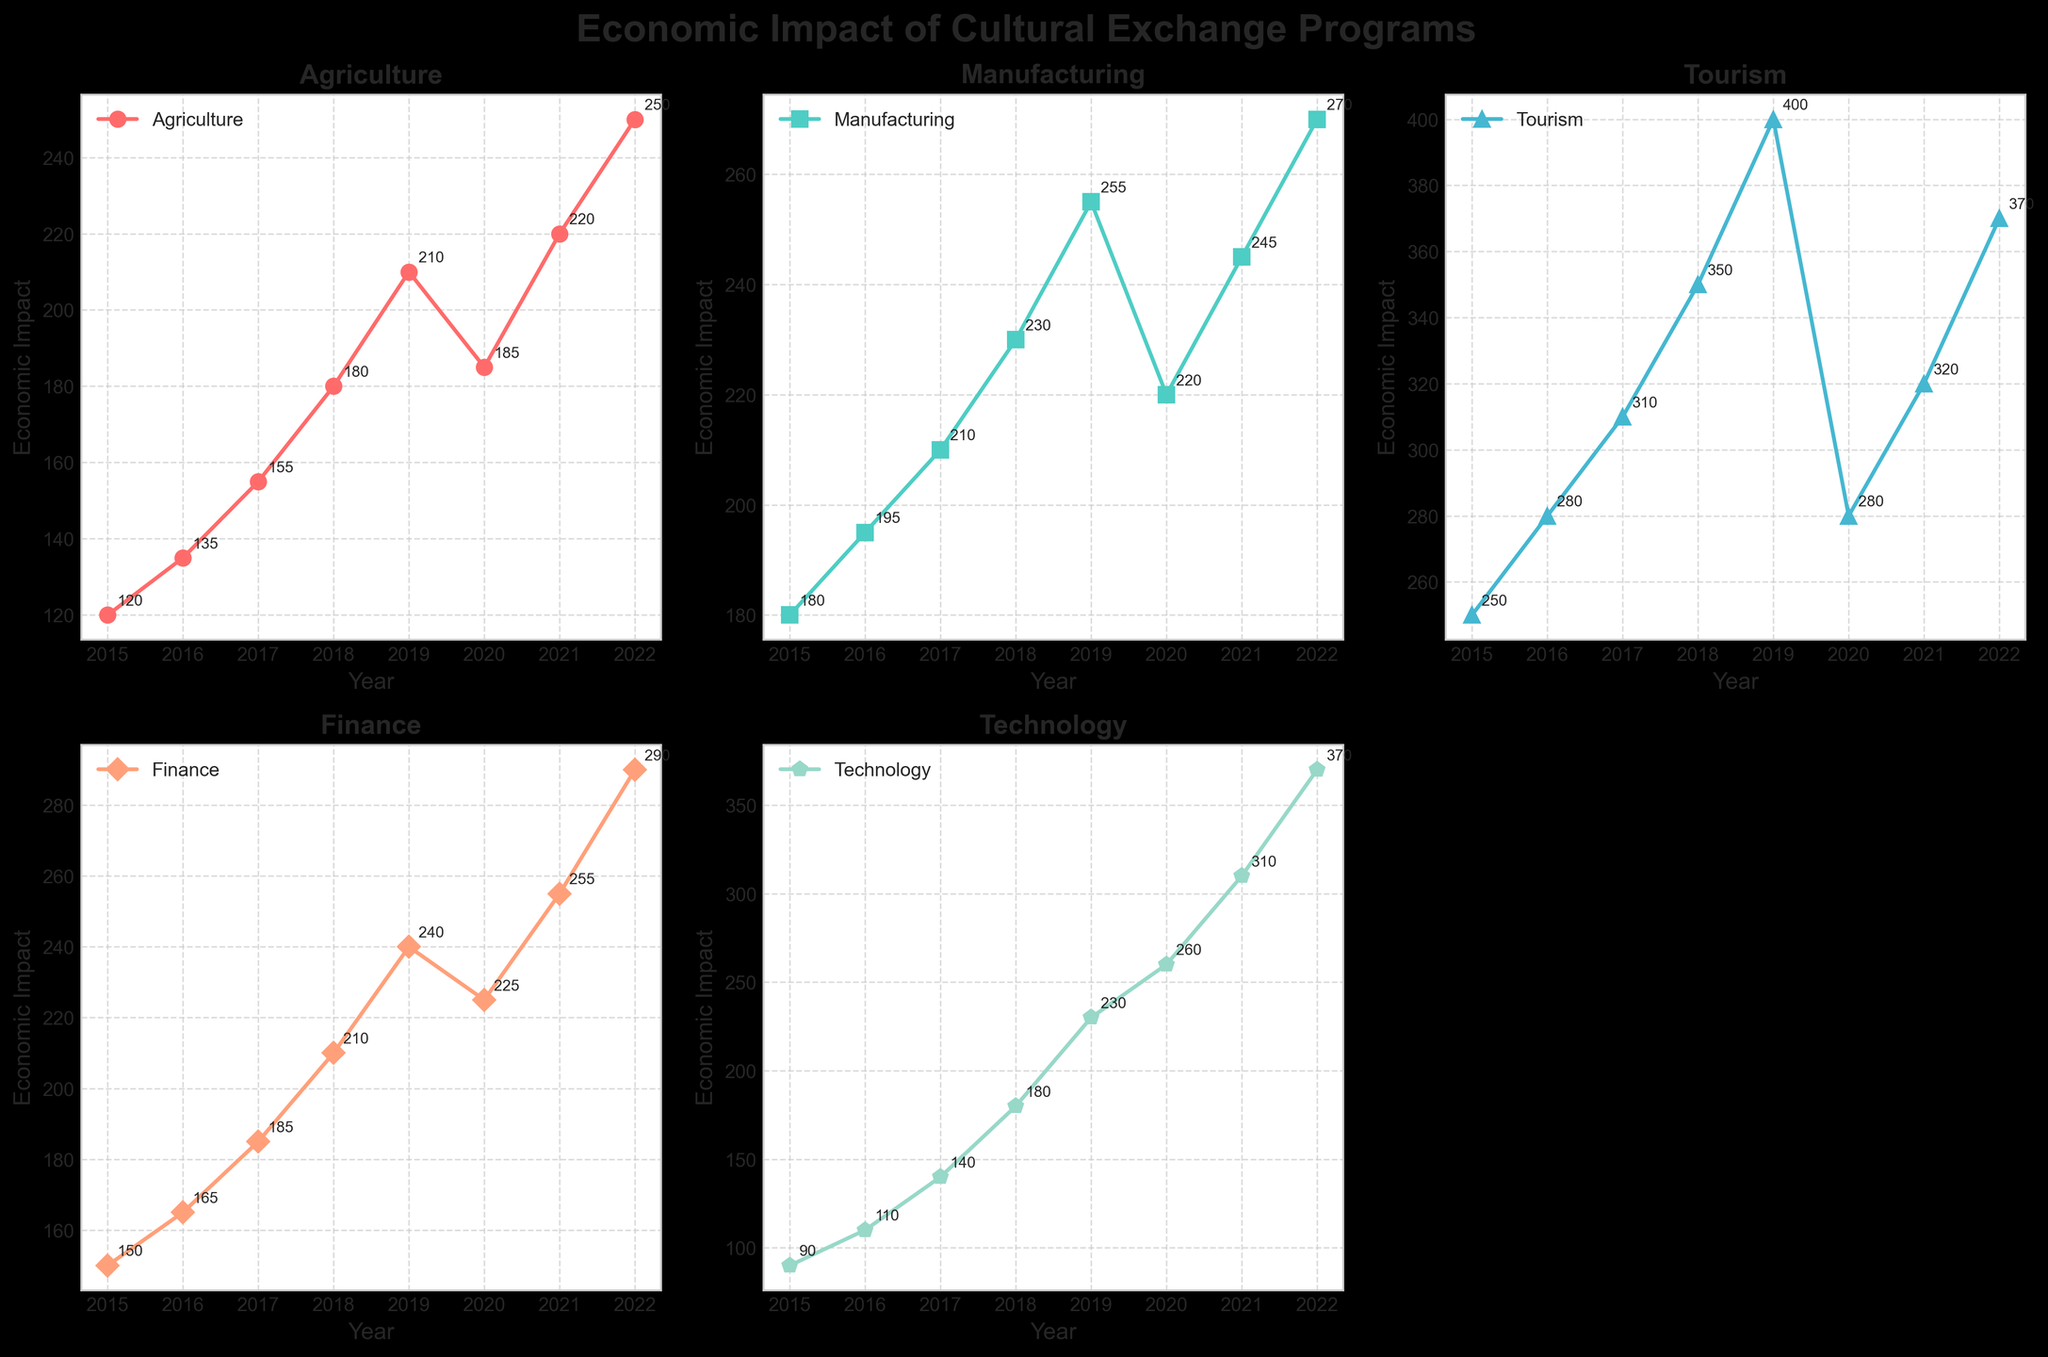What is the title of the figure? The title of the figure is displayed prominently at the top of the chart. It summarizes the topic of the visual data presented.
Answer: "Economic Impact of Cultural Exchange Programs" How many industries are depicted in the figure? By examining the subplots, we can count the number of unique industry sectors being represented.
Answer: 5 In which year did the Tourism sector experience the highest economic impact? By looking at the Tourism subplot and identifying the year with the highest data point, we determine the peak.
Answer: 2019 Which sector had a higher economic impact in 2020, Agriculture or Finance? In the subplots for Agriculture and Finance, compare the values at the year 2020.
Answer: Finance What is the overall trend of the Technology sector throughout the years? Observing the subplot for Technology, we can describe how the values change from 2015 to 2022.
Answer: Increasing Which year had the lowest impact on Manufacturing? Check the Manufacturing subplot and identify the smallest data point and its corresponding year.
Answer: 2015 How many years did the Agriculture sector experience a consistent increase before 2020? Look at the Agriculture subplot and count the consecutive years of increase starting from 2015 up to 2020.
Answer: 5 What is the average economic impact of the Technology sector from 2015 to 2022? Calculate the average by summing the data points for Technology and dividing by the number of years (8).
Answer: 211.25 Which sector faced a decline in economic impact in 2020 compared to 2019? Check each of the subplots for a drop in values from 2019 to 2020.
Answer: Tourism What is the difference in economic impact between Agriculture and Manufacturing in 2022? Subtract the value of Manufacturing from the value of Agriculture in the year 2022 in their respective subplots.
Answer: -20 